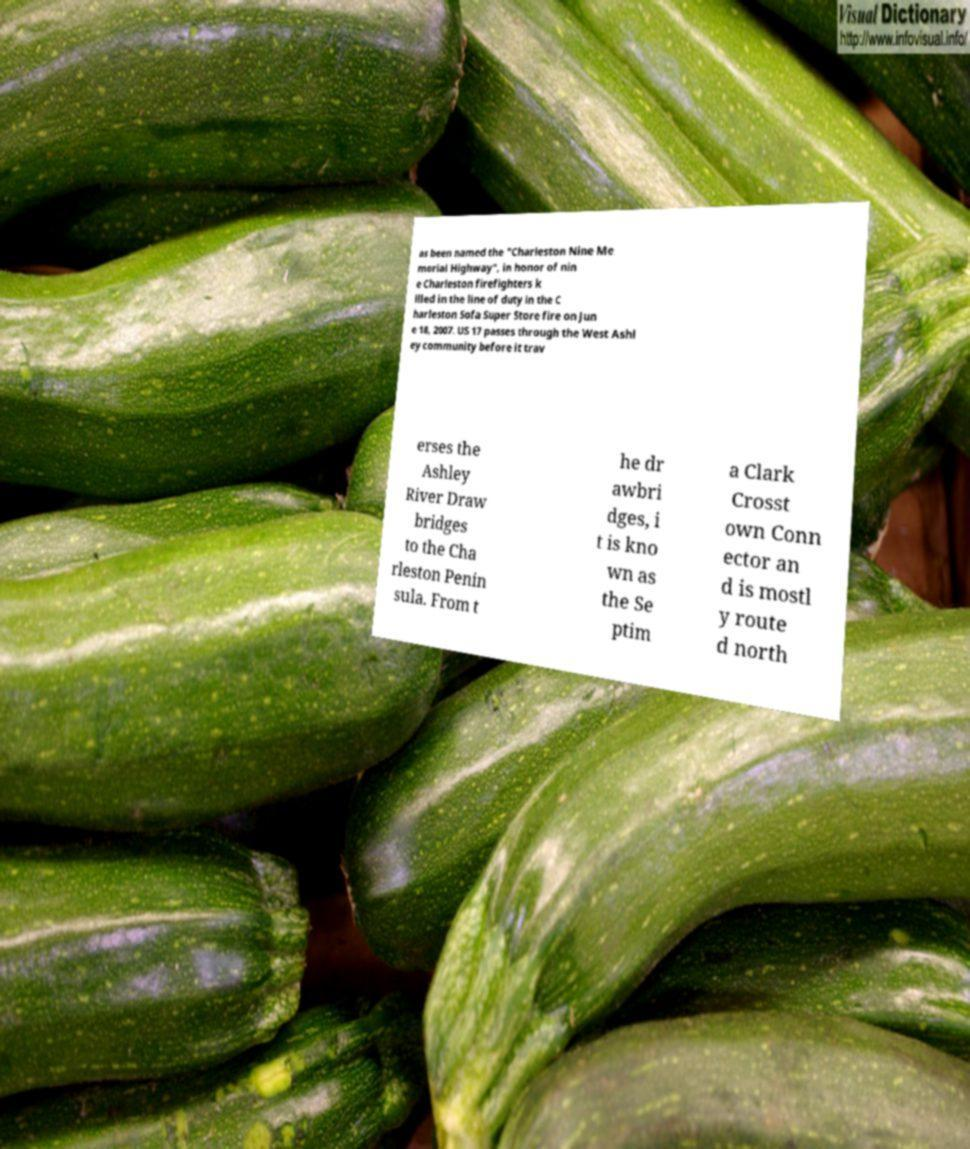Please identify and transcribe the text found in this image. as been named the "Charleston Nine Me morial Highway", in honor of nin e Charleston firefighters k illed in the line of duty in the C harleston Sofa Super Store fire on Jun e 18, 2007. US 17 passes through the West Ashl ey community before it trav erses the Ashley River Draw bridges to the Cha rleston Penin sula. From t he dr awbri dges, i t is kno wn as the Se ptim a Clark Crosst own Conn ector an d is mostl y route d north 